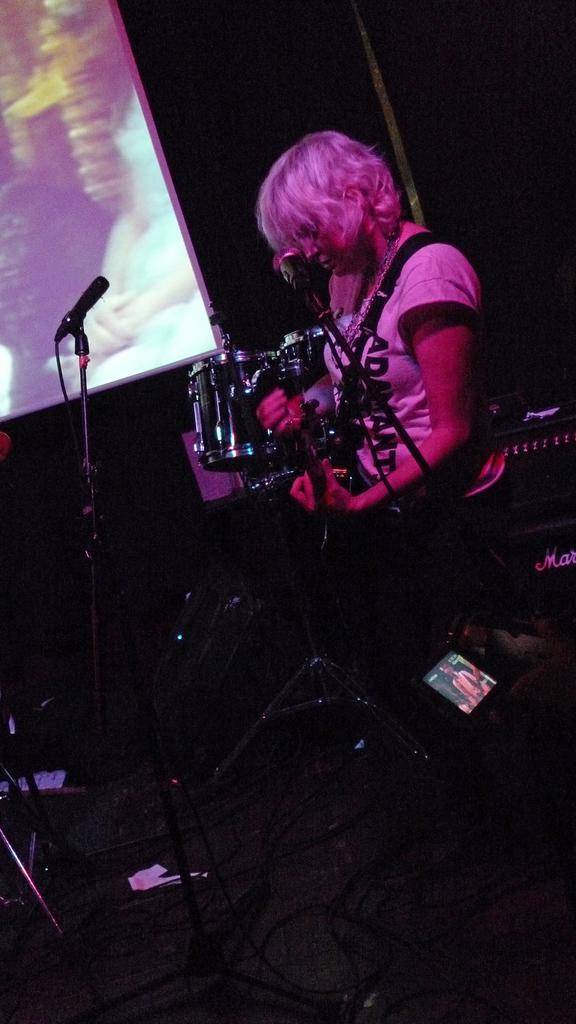Can you describe this image briefly? Background portion of the picture is dark and we can see a screen. On the right side of the picture we can see a person playing a musical instrument. In this picture we can see musical instruments and at the bottom we can see wires. Near to a person we can see a mike and stand. 